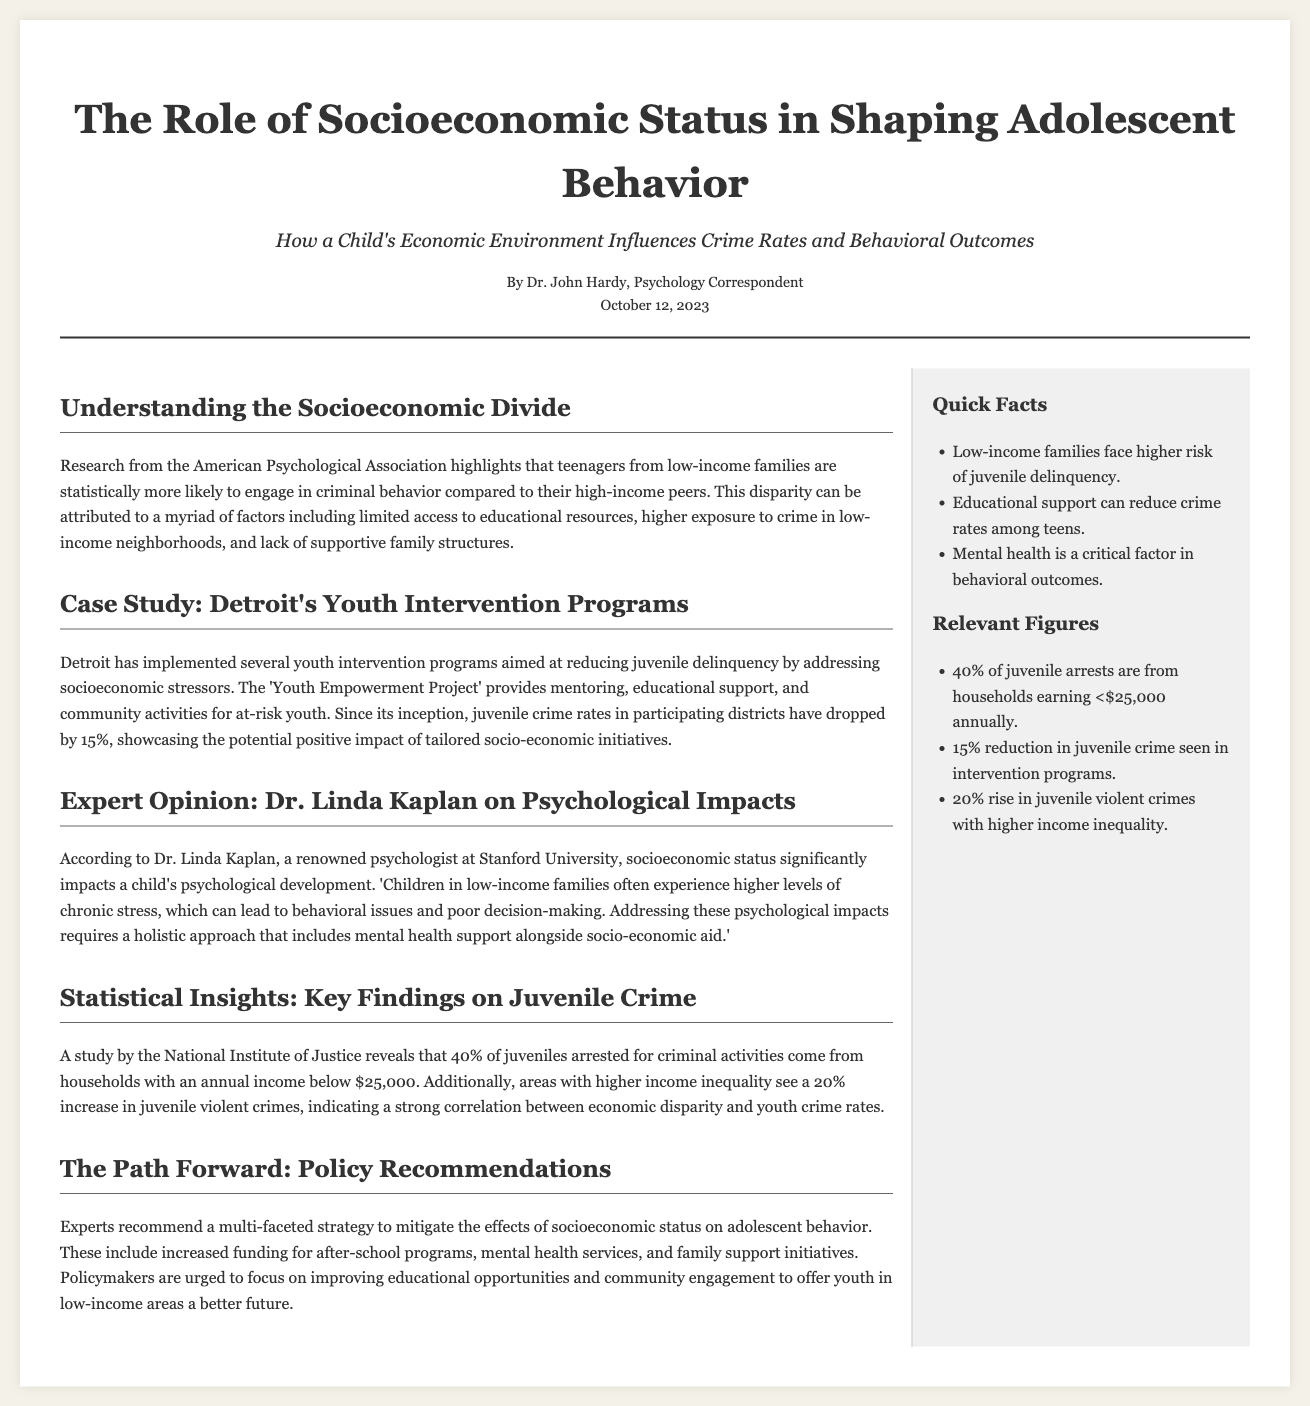what is the title of the article? The title of the article is prominently displayed at the top, indicating the main topic of focus within the document.
Answer: The Role of Socioeconomic Status in Shaping Adolescent Behavior who is the author of the article? The name of the author is mentioned directly below the title, providing credit to the individual who has written the piece.
Answer: Dr. John Hardy what date was the article published? The publication date is indicated right below the author's name, providing a clear temporal context for the article.
Answer: October 12, 2023 what percentage of juveniles arrested come from low-income households? This information is specifically mentioned in the statistical insights section, highlighting a critical finding from a study.
Answer: 40% what is the name of the youth intervention program mentioned in the case study? The youth intervention program's name is cited within the case study, illustrating an example of an initiative aimed at addressing juvenile delinquency.
Answer: Youth Empowerment Project how much has juvenile crime rates dropped in participating districts due to intervention programs? The document contains this statistic to illustrate the effectiveness of the mentioned programs in reducing crime rates.
Answer: 15% what is one recommended strategy to address socioeconomic effects on adolescents? The article suggests a few multi-faceted strategies, with this one being a key point made in the policy recommendations section.
Answer: Increased funding for after-school programs who comments on the psychological impacts of socioeconomic status? The document includes an expert opinion section that refers to this individual as having relevant insights on the topic discussed.
Answer: Dr. Linda Kaplan what was the increase in juvenile violent crimes in areas with higher income inequality? The document provides this statistic in the statistical insights section, showing the correlation between economic factors and juvenile crime.
Answer: 20% 